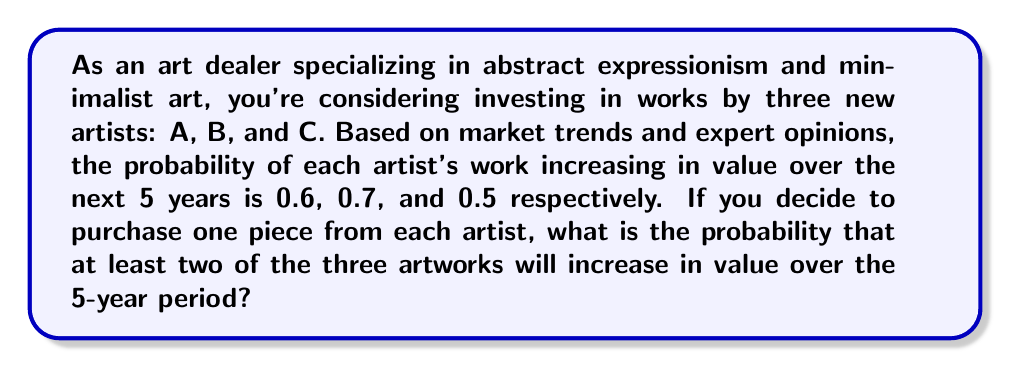Can you solve this math problem? To solve this problem, we'll use the concept of probability and the complement rule. Let's break it down step by step:

1) First, let's define our events:
   A: Artist A's work increases in value
   B: Artist B's work increases in value
   C: Artist C's work increases in value

2) We're looking for the probability of at least two artworks increasing in value. It's easier to calculate the complement of this event, which is the probability of 0 or 1 artwork increasing in value, and then subtract from 1.

3) Probability of 0 artworks increasing in value:
   $P(\text{none}) = (1-0.6)(1-0.7)(1-0.5) = 0.4 \times 0.3 \times 0.5 = 0.06$

4) Probability of exactly 1 artwork increasing in value:
   $P(\text{only A}) = 0.6 \times 0.3 \times 0.5 = 0.09$
   $P(\text{only B}) = 0.4 \times 0.7 \times 0.5 = 0.14$
   $P(\text{only C}) = 0.4 \times 0.3 \times 0.5 = 0.06$
   
   $P(\text{exactly one}) = 0.09 + 0.14 + 0.06 = 0.29$

5) Probability of 0 or 1 artwork increasing in value:
   $P(0 \text{ or } 1) = 0.06 + 0.29 = 0.35$

6) Therefore, the probability of at least 2 artworks increasing in value is:
   $P(\text{at least 2}) = 1 - P(0 \text{ or } 1) = 1 - 0.35 = 0.65$
Answer: The probability that at least two of the three artworks will increase in value over the 5-year period is 0.65 or 65%. 